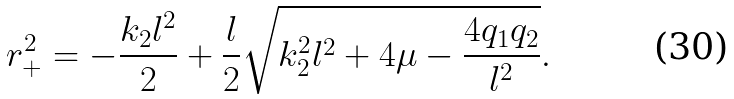Convert formula to latex. <formula><loc_0><loc_0><loc_500><loc_500>r _ { + } ^ { 2 } = - \frac { k _ { 2 } l ^ { 2 } } { 2 } + { \frac { l } { 2 } } \sqrt { k _ { 2 } ^ { 2 } l ^ { 2 } + 4 \mu - \frac { 4 q _ { 1 } q _ { 2 } } { l ^ { 2 } } } .</formula> 